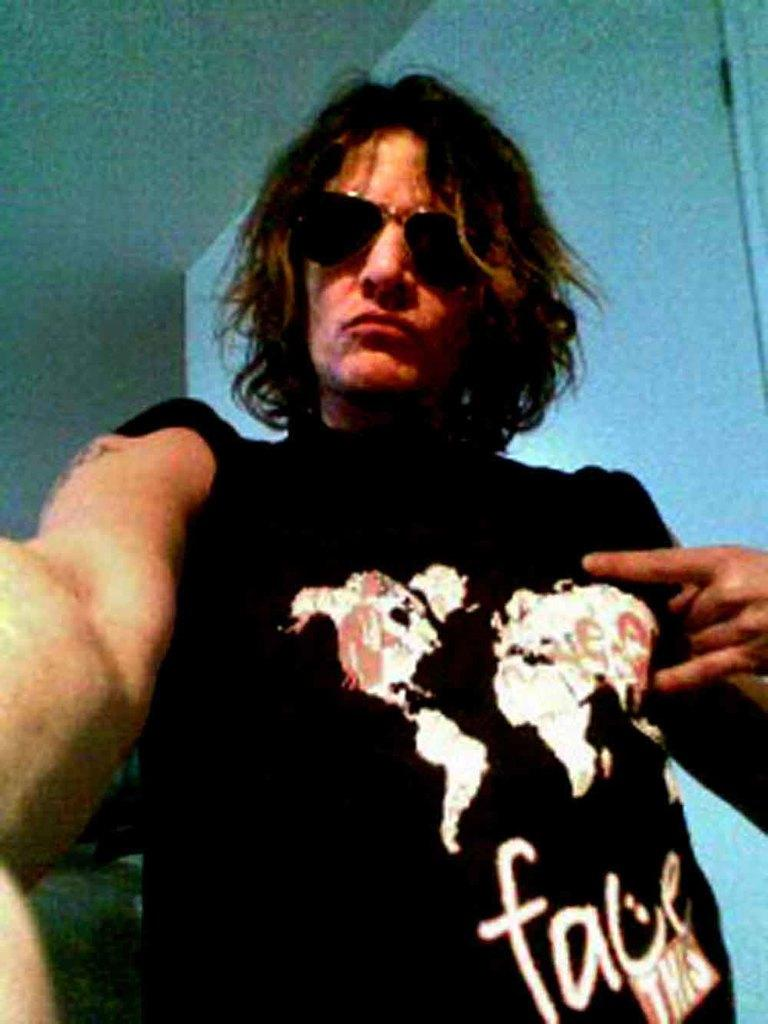What is the main subject of the image? There is a man in the image. What is the man wearing on his upper body? The man is wearing a t-shirt. What accessory is the man wearing on his face? The man is wearing spectacles. What type of meal is the man preparing on the table in the image? There is no table or meal preparation visible in the image; it only features a man wearing a t-shirt and spectacles. 